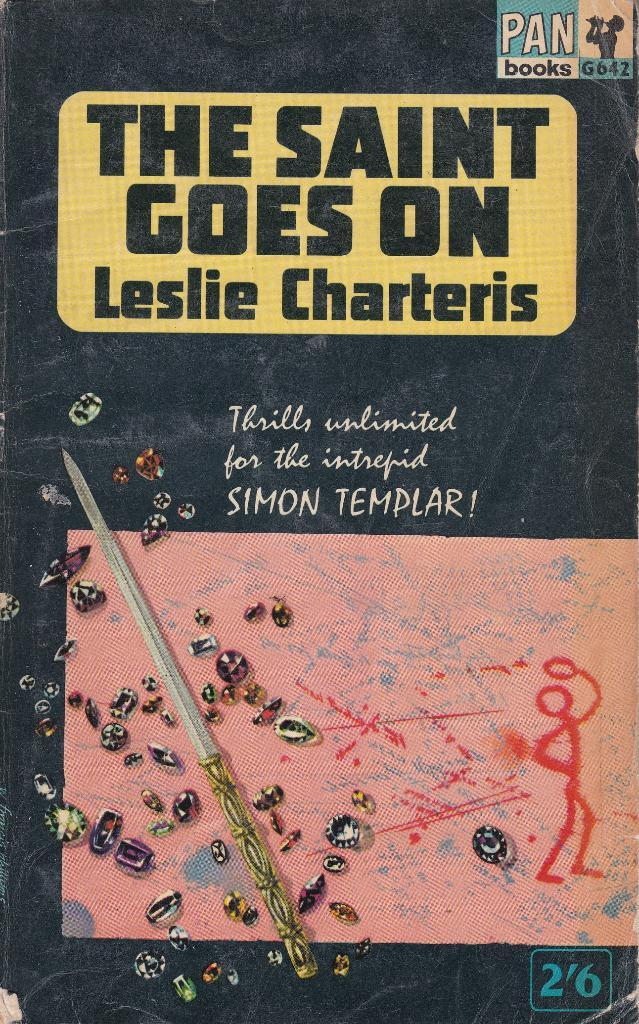<image>
Share a concise interpretation of the image provided. A copy of The Saint Goes On by Leslie Charteris promises Thrills unlimited for the intrepid SIMON TEMPLAR! 